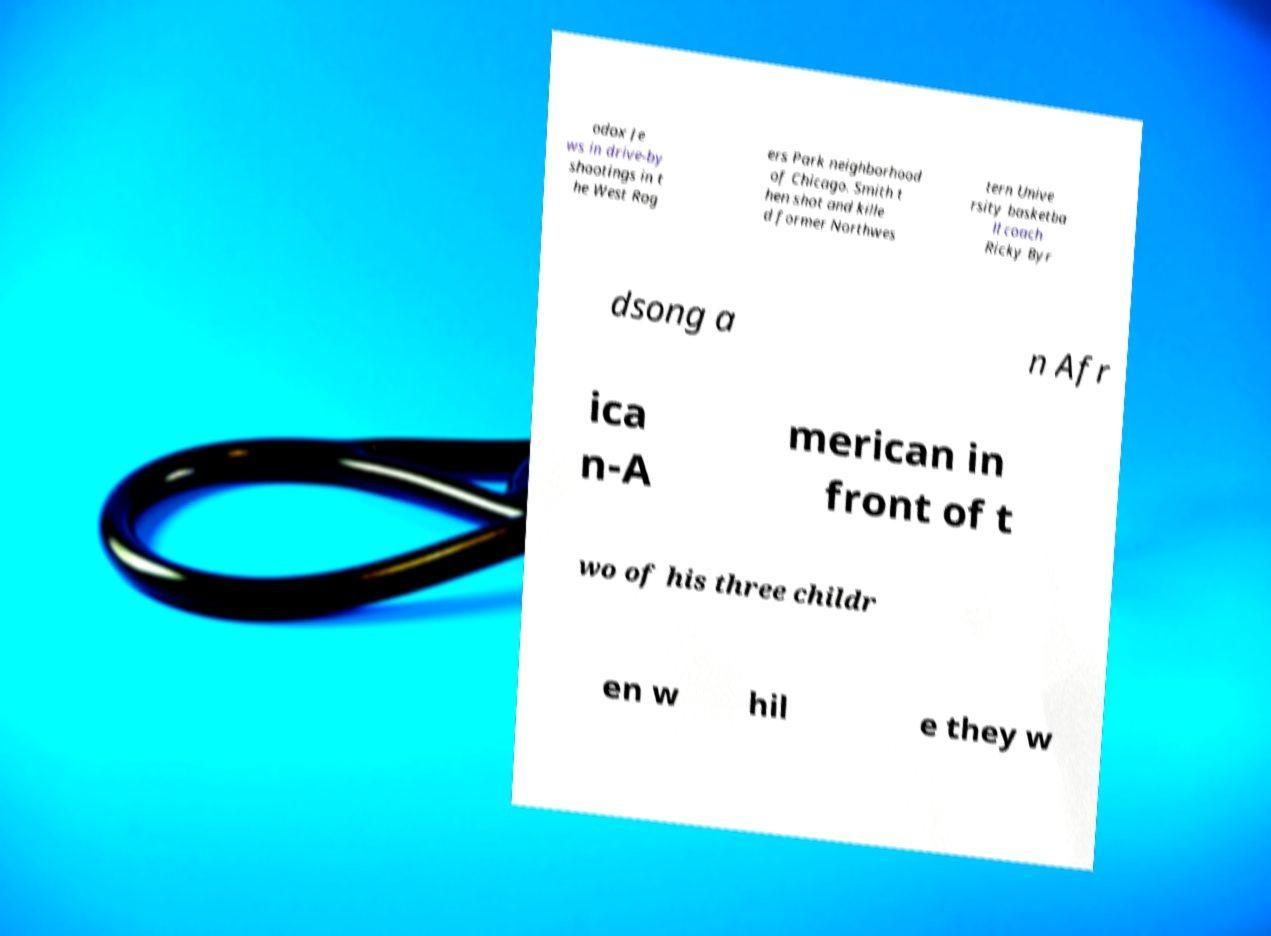Please identify and transcribe the text found in this image. odox Je ws in drive-by shootings in t he West Rog ers Park neighborhood of Chicago. Smith t hen shot and kille d former Northwes tern Unive rsity basketba ll coach Ricky Byr dsong a n Afr ica n-A merican in front of t wo of his three childr en w hil e they w 